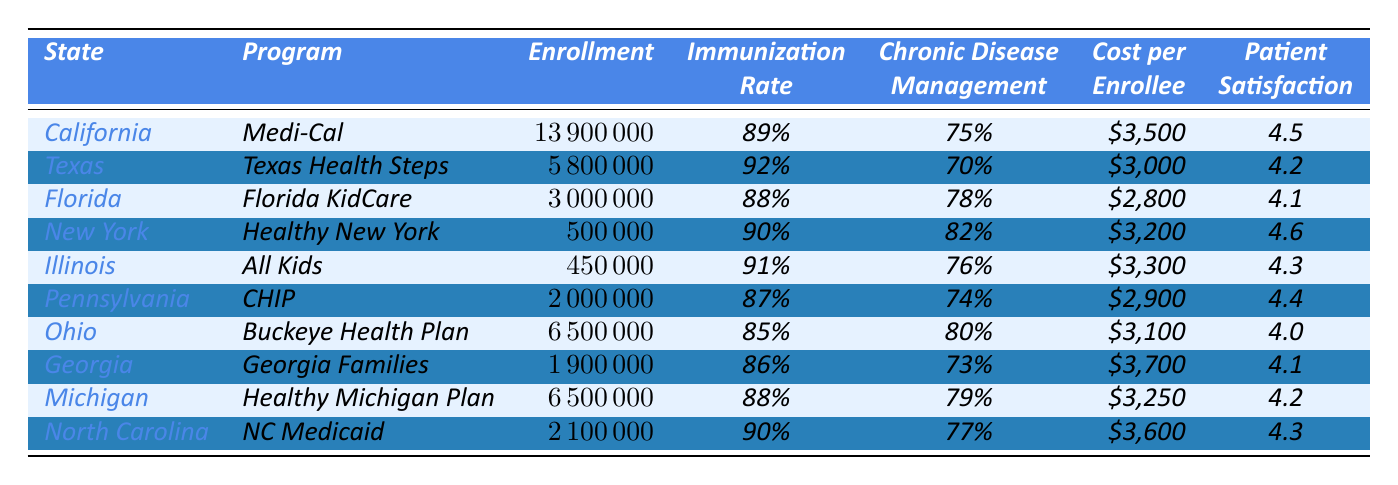What is the immunization rate for Texas? The immunization rate for Texas, listed under the immunization rate column, is 92%.
Answer: 92% Which state has the highest patient satisfaction score? The patient satisfaction scores are 4.5 for California and 4.6 for New York. New York has the highest score at 4.6.
Answer: New York How many enrollees are there in Ohio's Buckeye Health Plan? The enrollment for Ohio's Buckeye Health Plan is 6,500,000, as found in the enrollment column for Ohio.
Answer: 6,500,000 What is the average cost per enrollee across all programs? The total cost for all programs is calculated as follows: (3500 + 3000 + 2800 + 3200 + 3300 + 2900 + 3100 + 3700 + 3250 + 3600) = 30,350. There are 10 programs, so the average cost is 30,350 / 10 = 3,035.
Answer: 3,035 Which state has the lowest immunization rate and what is that rate? The lowest immunization rate is for Ohio, which has an immunization rate of 85%, as listed in the immunization rate column.
Answer: 85% Is the chronic disease management rate for Florida higher than that for Texas? Florida's chronic disease management rate is 78%, while Texas has a rate of 70%. Therefore, Florida's rate is higher.
Answer: Yes What is the total enrollment in all the programs combined? The total enrollment is calculated by adding all individual enrollments: (13,900,000 + 5,800,000 + 3,000,000 + 500,000 + 450,000 + 2,000,000 + 6,500,000 + 1,900,000 + 6,500,000 + 2,100,000) = 42,700,000.
Answer: 42,700,000 Does Illinois have a chronic disease management rate of 76%? Illinois's chronic disease management rate is indeed 76%, as noted in the chronic disease management column for Illinois.
Answer: Yes How many more enrollees does California have than Florida? The difference in enrollment between California and Florida is 13,900,000 - 3,000,000 = 10,900,000.
Answer: 10,900,000 Which state has the lowest enrollment and what is the enrollment number? The state with the lowest enrollment is New York, with 500,000 enrollees listed under the enrollment column.
Answer: 500,000 